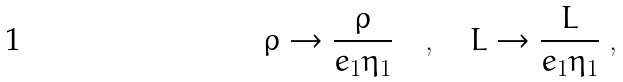<formula> <loc_0><loc_0><loc_500><loc_500>\rho \rightarrow \frac { \rho } { e _ { 1 } \eta _ { 1 } } \quad , \quad L \rightarrow \frac { L } { e _ { 1 } \eta _ { 1 } } \ ,</formula> 